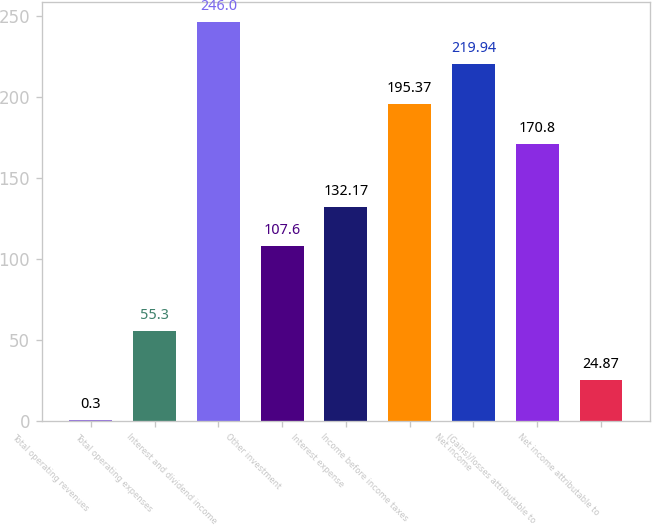Convert chart. <chart><loc_0><loc_0><loc_500><loc_500><bar_chart><fcel>Total operating revenues<fcel>Total operating expenses<fcel>Interest and dividend income<fcel>Other investment<fcel>Interest expense<fcel>Income before income taxes<fcel>Net income<fcel>(Gains)/losses attributable to<fcel>Net income attributable to<nl><fcel>0.3<fcel>55.3<fcel>246<fcel>107.6<fcel>132.17<fcel>195.37<fcel>219.94<fcel>170.8<fcel>24.87<nl></chart> 